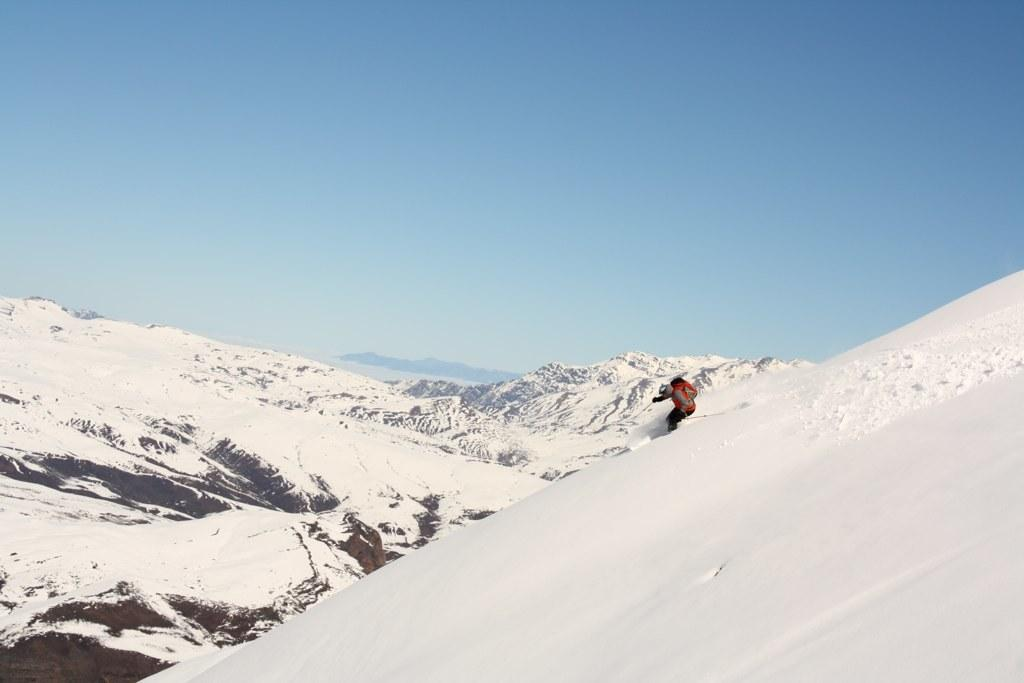What activity is the person in the image engaged in? The person is skiing in the image. What surface is the person skiing on? The person is skiing in snow. What can be seen in the background of the image? There are mountains in the background of the image. What is the condition of the mountains in the image? The mountains are covered with snow. What type of yarn is the person using to ski in the image? There is no yarn present in the image; the person is skiing on snow using skis. 